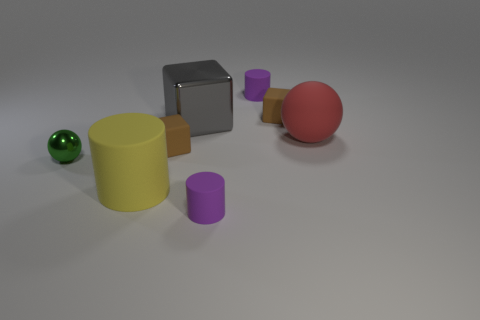How would you describe the arrangement of the objects? The objects are arranged in a seemingly random manner on a flat surface with no discernible pattern. They are spaced apart with no two objects touching each other. 